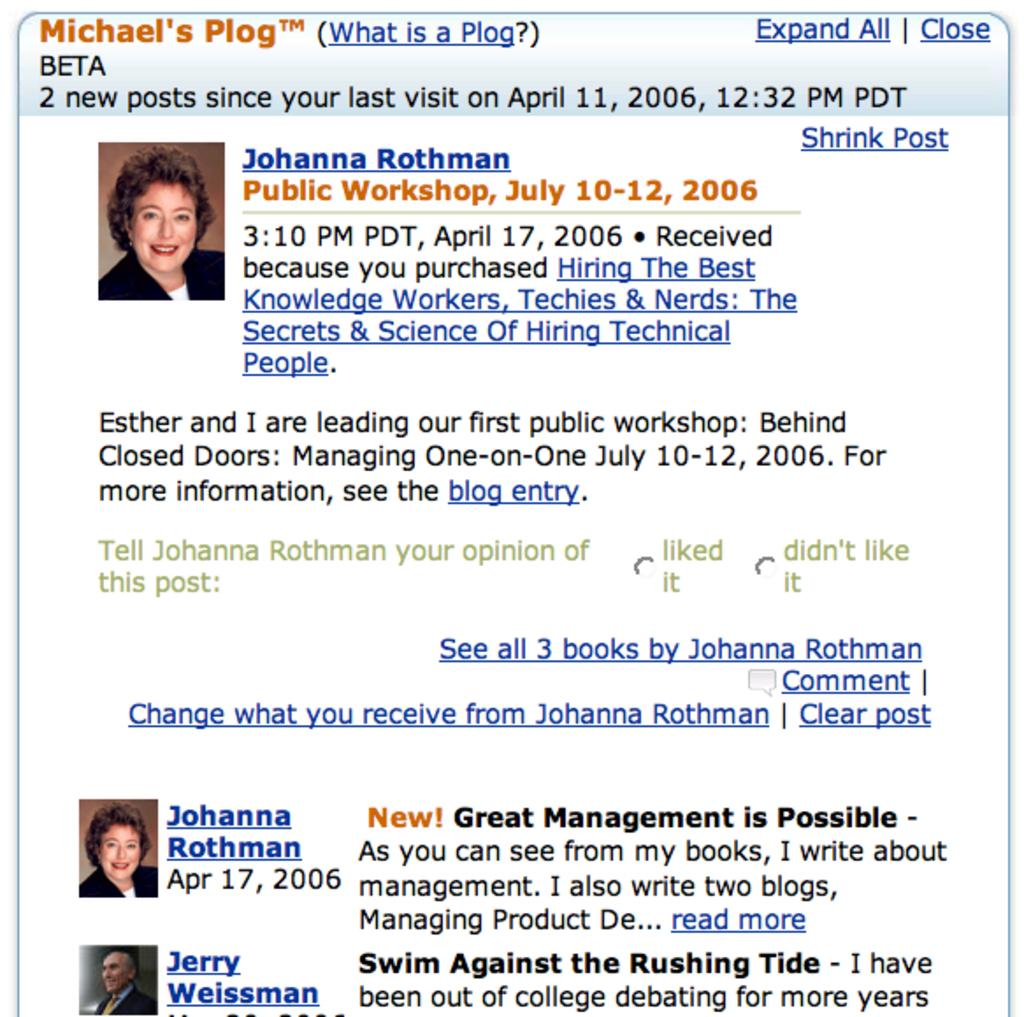Where was the image obtained from? The image is taken from a website. What type of content is featured in the image? The image contains information related to a workshop. What type of roof is visible in the image? There is no roof visible in the image, as it contains information related to a workshop rather than a physical location. 